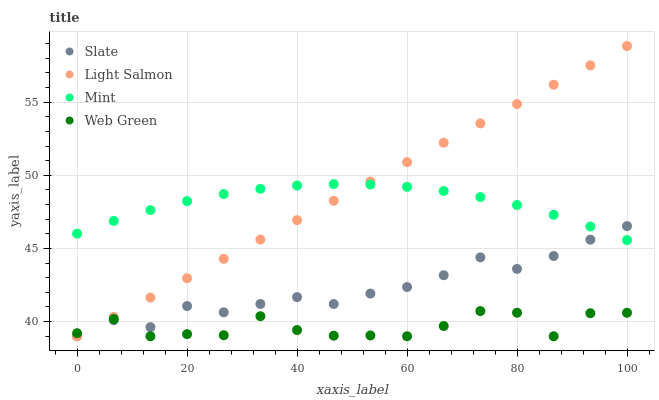Does Web Green have the minimum area under the curve?
Answer yes or no. Yes. Does Light Salmon have the maximum area under the curve?
Answer yes or no. Yes. Does Mint have the minimum area under the curve?
Answer yes or no. No. Does Mint have the maximum area under the curve?
Answer yes or no. No. Is Light Salmon the smoothest?
Answer yes or no. Yes. Is Web Green the roughest?
Answer yes or no. Yes. Is Mint the smoothest?
Answer yes or no. No. Is Mint the roughest?
Answer yes or no. No. Does Slate have the lowest value?
Answer yes or no. Yes. Does Mint have the lowest value?
Answer yes or no. No. Does Light Salmon have the highest value?
Answer yes or no. Yes. Does Mint have the highest value?
Answer yes or no. No. Is Web Green less than Mint?
Answer yes or no. Yes. Is Mint greater than Web Green?
Answer yes or no. Yes. Does Light Salmon intersect Web Green?
Answer yes or no. Yes. Is Light Salmon less than Web Green?
Answer yes or no. No. Is Light Salmon greater than Web Green?
Answer yes or no. No. Does Web Green intersect Mint?
Answer yes or no. No. 